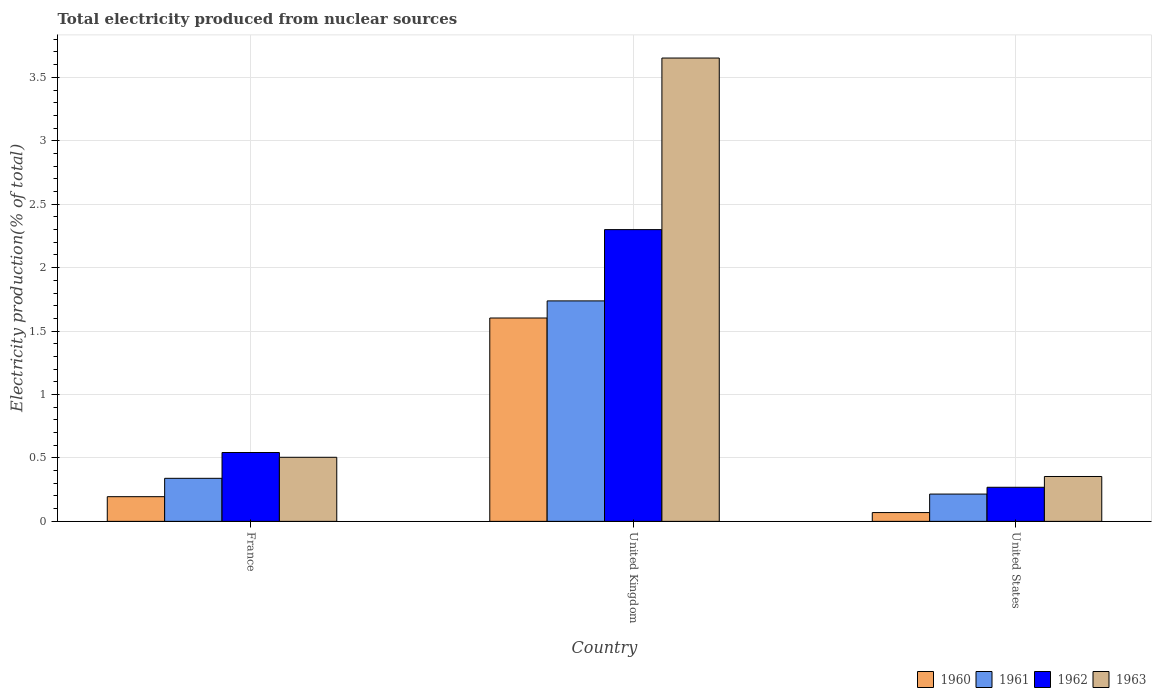Are the number of bars on each tick of the X-axis equal?
Provide a succinct answer. Yes. How many bars are there on the 3rd tick from the right?
Give a very brief answer. 4. What is the label of the 2nd group of bars from the left?
Keep it short and to the point. United Kingdom. What is the total electricity produced in 1962 in United Kingdom?
Offer a very short reply. 2.3. Across all countries, what is the maximum total electricity produced in 1961?
Your answer should be compact. 1.74. Across all countries, what is the minimum total electricity produced in 1963?
Offer a very short reply. 0.35. What is the total total electricity produced in 1960 in the graph?
Provide a short and direct response. 1.87. What is the difference between the total electricity produced in 1962 in France and that in United States?
Your response must be concise. 0.27. What is the difference between the total electricity produced in 1963 in United Kingdom and the total electricity produced in 1960 in France?
Your answer should be compact. 3.46. What is the average total electricity produced in 1962 per country?
Ensure brevity in your answer.  1.04. What is the difference between the total electricity produced of/in 1961 and total electricity produced of/in 1963 in France?
Offer a terse response. -0.17. What is the ratio of the total electricity produced in 1962 in United Kingdom to that in United States?
Ensure brevity in your answer.  8.56. Is the total electricity produced in 1960 in France less than that in United States?
Your answer should be very brief. No. Is the difference between the total electricity produced in 1961 in France and United Kingdom greater than the difference between the total electricity produced in 1963 in France and United Kingdom?
Provide a succinct answer. Yes. What is the difference between the highest and the second highest total electricity produced in 1962?
Keep it short and to the point. 0.27. What is the difference between the highest and the lowest total electricity produced in 1962?
Provide a short and direct response. 2.03. Is the sum of the total electricity produced in 1962 in France and United States greater than the maximum total electricity produced in 1963 across all countries?
Give a very brief answer. No. Is it the case that in every country, the sum of the total electricity produced in 1961 and total electricity produced in 1963 is greater than the sum of total electricity produced in 1960 and total electricity produced in 1962?
Provide a succinct answer. No. What does the 2nd bar from the left in United Kingdom represents?
Make the answer very short. 1961. Is it the case that in every country, the sum of the total electricity produced in 1961 and total electricity produced in 1960 is greater than the total electricity produced in 1962?
Provide a succinct answer. No. How many bars are there?
Provide a succinct answer. 12. Are all the bars in the graph horizontal?
Your answer should be compact. No. What is the difference between two consecutive major ticks on the Y-axis?
Ensure brevity in your answer.  0.5. Are the values on the major ticks of Y-axis written in scientific E-notation?
Make the answer very short. No. How many legend labels are there?
Provide a succinct answer. 4. What is the title of the graph?
Keep it short and to the point. Total electricity produced from nuclear sources. Does "2010" appear as one of the legend labels in the graph?
Your response must be concise. No. What is the label or title of the X-axis?
Your response must be concise. Country. What is the Electricity production(% of total) of 1960 in France?
Make the answer very short. 0.19. What is the Electricity production(% of total) of 1961 in France?
Ensure brevity in your answer.  0.34. What is the Electricity production(% of total) in 1962 in France?
Your response must be concise. 0.54. What is the Electricity production(% of total) of 1963 in France?
Give a very brief answer. 0.51. What is the Electricity production(% of total) of 1960 in United Kingdom?
Give a very brief answer. 1.6. What is the Electricity production(% of total) in 1961 in United Kingdom?
Give a very brief answer. 1.74. What is the Electricity production(% of total) in 1962 in United Kingdom?
Your answer should be compact. 2.3. What is the Electricity production(% of total) in 1963 in United Kingdom?
Keep it short and to the point. 3.65. What is the Electricity production(% of total) in 1960 in United States?
Offer a terse response. 0.07. What is the Electricity production(% of total) in 1961 in United States?
Provide a short and direct response. 0.22. What is the Electricity production(% of total) in 1962 in United States?
Your response must be concise. 0.27. What is the Electricity production(% of total) in 1963 in United States?
Your answer should be compact. 0.35. Across all countries, what is the maximum Electricity production(% of total) of 1960?
Provide a short and direct response. 1.6. Across all countries, what is the maximum Electricity production(% of total) in 1961?
Keep it short and to the point. 1.74. Across all countries, what is the maximum Electricity production(% of total) of 1962?
Keep it short and to the point. 2.3. Across all countries, what is the maximum Electricity production(% of total) in 1963?
Ensure brevity in your answer.  3.65. Across all countries, what is the minimum Electricity production(% of total) in 1960?
Provide a short and direct response. 0.07. Across all countries, what is the minimum Electricity production(% of total) in 1961?
Make the answer very short. 0.22. Across all countries, what is the minimum Electricity production(% of total) of 1962?
Give a very brief answer. 0.27. Across all countries, what is the minimum Electricity production(% of total) of 1963?
Offer a terse response. 0.35. What is the total Electricity production(% of total) in 1960 in the graph?
Give a very brief answer. 1.87. What is the total Electricity production(% of total) of 1961 in the graph?
Provide a short and direct response. 2.29. What is the total Electricity production(% of total) of 1962 in the graph?
Your answer should be compact. 3.11. What is the total Electricity production(% of total) in 1963 in the graph?
Keep it short and to the point. 4.51. What is the difference between the Electricity production(% of total) in 1960 in France and that in United Kingdom?
Provide a short and direct response. -1.41. What is the difference between the Electricity production(% of total) of 1961 in France and that in United Kingdom?
Keep it short and to the point. -1.4. What is the difference between the Electricity production(% of total) of 1962 in France and that in United Kingdom?
Give a very brief answer. -1.76. What is the difference between the Electricity production(% of total) of 1963 in France and that in United Kingdom?
Your response must be concise. -3.15. What is the difference between the Electricity production(% of total) of 1960 in France and that in United States?
Your response must be concise. 0.13. What is the difference between the Electricity production(% of total) in 1961 in France and that in United States?
Keep it short and to the point. 0.12. What is the difference between the Electricity production(% of total) in 1962 in France and that in United States?
Provide a succinct answer. 0.27. What is the difference between the Electricity production(% of total) in 1963 in France and that in United States?
Ensure brevity in your answer.  0.15. What is the difference between the Electricity production(% of total) of 1960 in United Kingdom and that in United States?
Provide a succinct answer. 1.53. What is the difference between the Electricity production(% of total) in 1961 in United Kingdom and that in United States?
Offer a terse response. 1.52. What is the difference between the Electricity production(% of total) in 1962 in United Kingdom and that in United States?
Keep it short and to the point. 2.03. What is the difference between the Electricity production(% of total) in 1963 in United Kingdom and that in United States?
Keep it short and to the point. 3.3. What is the difference between the Electricity production(% of total) in 1960 in France and the Electricity production(% of total) in 1961 in United Kingdom?
Offer a terse response. -1.54. What is the difference between the Electricity production(% of total) of 1960 in France and the Electricity production(% of total) of 1962 in United Kingdom?
Your answer should be compact. -2.11. What is the difference between the Electricity production(% of total) of 1960 in France and the Electricity production(% of total) of 1963 in United Kingdom?
Keep it short and to the point. -3.46. What is the difference between the Electricity production(% of total) in 1961 in France and the Electricity production(% of total) in 1962 in United Kingdom?
Your answer should be compact. -1.96. What is the difference between the Electricity production(% of total) of 1961 in France and the Electricity production(% of total) of 1963 in United Kingdom?
Provide a short and direct response. -3.31. What is the difference between the Electricity production(% of total) in 1962 in France and the Electricity production(% of total) in 1963 in United Kingdom?
Your answer should be compact. -3.11. What is the difference between the Electricity production(% of total) in 1960 in France and the Electricity production(% of total) in 1961 in United States?
Keep it short and to the point. -0.02. What is the difference between the Electricity production(% of total) of 1960 in France and the Electricity production(% of total) of 1962 in United States?
Provide a short and direct response. -0.07. What is the difference between the Electricity production(% of total) in 1960 in France and the Electricity production(% of total) in 1963 in United States?
Offer a very short reply. -0.16. What is the difference between the Electricity production(% of total) of 1961 in France and the Electricity production(% of total) of 1962 in United States?
Give a very brief answer. 0.07. What is the difference between the Electricity production(% of total) of 1961 in France and the Electricity production(% of total) of 1963 in United States?
Ensure brevity in your answer.  -0.01. What is the difference between the Electricity production(% of total) of 1962 in France and the Electricity production(% of total) of 1963 in United States?
Your answer should be compact. 0.19. What is the difference between the Electricity production(% of total) in 1960 in United Kingdom and the Electricity production(% of total) in 1961 in United States?
Offer a very short reply. 1.39. What is the difference between the Electricity production(% of total) of 1960 in United Kingdom and the Electricity production(% of total) of 1962 in United States?
Your answer should be compact. 1.33. What is the difference between the Electricity production(% of total) in 1960 in United Kingdom and the Electricity production(% of total) in 1963 in United States?
Provide a succinct answer. 1.25. What is the difference between the Electricity production(% of total) in 1961 in United Kingdom and the Electricity production(% of total) in 1962 in United States?
Offer a very short reply. 1.47. What is the difference between the Electricity production(% of total) in 1961 in United Kingdom and the Electricity production(% of total) in 1963 in United States?
Offer a terse response. 1.38. What is the difference between the Electricity production(% of total) in 1962 in United Kingdom and the Electricity production(% of total) in 1963 in United States?
Make the answer very short. 1.95. What is the average Electricity production(% of total) in 1960 per country?
Your response must be concise. 0.62. What is the average Electricity production(% of total) in 1961 per country?
Provide a short and direct response. 0.76. What is the average Electricity production(% of total) of 1962 per country?
Give a very brief answer. 1.04. What is the average Electricity production(% of total) in 1963 per country?
Your answer should be compact. 1.5. What is the difference between the Electricity production(% of total) of 1960 and Electricity production(% of total) of 1961 in France?
Your response must be concise. -0.14. What is the difference between the Electricity production(% of total) of 1960 and Electricity production(% of total) of 1962 in France?
Provide a short and direct response. -0.35. What is the difference between the Electricity production(% of total) in 1960 and Electricity production(% of total) in 1963 in France?
Ensure brevity in your answer.  -0.31. What is the difference between the Electricity production(% of total) of 1961 and Electricity production(% of total) of 1962 in France?
Offer a very short reply. -0.2. What is the difference between the Electricity production(% of total) in 1961 and Electricity production(% of total) in 1963 in France?
Your answer should be very brief. -0.17. What is the difference between the Electricity production(% of total) of 1962 and Electricity production(% of total) of 1963 in France?
Offer a terse response. 0.04. What is the difference between the Electricity production(% of total) of 1960 and Electricity production(% of total) of 1961 in United Kingdom?
Your answer should be compact. -0.13. What is the difference between the Electricity production(% of total) in 1960 and Electricity production(% of total) in 1962 in United Kingdom?
Provide a succinct answer. -0.7. What is the difference between the Electricity production(% of total) in 1960 and Electricity production(% of total) in 1963 in United Kingdom?
Your answer should be very brief. -2.05. What is the difference between the Electricity production(% of total) of 1961 and Electricity production(% of total) of 1962 in United Kingdom?
Give a very brief answer. -0.56. What is the difference between the Electricity production(% of total) of 1961 and Electricity production(% of total) of 1963 in United Kingdom?
Your response must be concise. -1.91. What is the difference between the Electricity production(% of total) in 1962 and Electricity production(% of total) in 1963 in United Kingdom?
Your answer should be very brief. -1.35. What is the difference between the Electricity production(% of total) of 1960 and Electricity production(% of total) of 1961 in United States?
Your response must be concise. -0.15. What is the difference between the Electricity production(% of total) in 1960 and Electricity production(% of total) in 1962 in United States?
Give a very brief answer. -0.2. What is the difference between the Electricity production(% of total) in 1960 and Electricity production(% of total) in 1963 in United States?
Offer a very short reply. -0.28. What is the difference between the Electricity production(% of total) in 1961 and Electricity production(% of total) in 1962 in United States?
Your response must be concise. -0.05. What is the difference between the Electricity production(% of total) of 1961 and Electricity production(% of total) of 1963 in United States?
Make the answer very short. -0.14. What is the difference between the Electricity production(% of total) of 1962 and Electricity production(% of total) of 1963 in United States?
Provide a succinct answer. -0.09. What is the ratio of the Electricity production(% of total) in 1960 in France to that in United Kingdom?
Your response must be concise. 0.12. What is the ratio of the Electricity production(% of total) of 1961 in France to that in United Kingdom?
Give a very brief answer. 0.2. What is the ratio of the Electricity production(% of total) in 1962 in France to that in United Kingdom?
Offer a very short reply. 0.24. What is the ratio of the Electricity production(% of total) of 1963 in France to that in United Kingdom?
Your answer should be very brief. 0.14. What is the ratio of the Electricity production(% of total) of 1960 in France to that in United States?
Ensure brevity in your answer.  2.81. What is the ratio of the Electricity production(% of total) in 1961 in France to that in United States?
Your response must be concise. 1.58. What is the ratio of the Electricity production(% of total) in 1962 in France to that in United States?
Provide a short and direct response. 2.02. What is the ratio of the Electricity production(% of total) in 1963 in France to that in United States?
Provide a succinct answer. 1.43. What is the ratio of the Electricity production(% of total) in 1960 in United Kingdom to that in United States?
Provide a succinct answer. 23.14. What is the ratio of the Electricity production(% of total) in 1961 in United Kingdom to that in United States?
Provide a short and direct response. 8.08. What is the ratio of the Electricity production(% of total) in 1962 in United Kingdom to that in United States?
Ensure brevity in your answer.  8.56. What is the ratio of the Electricity production(% of total) in 1963 in United Kingdom to that in United States?
Keep it short and to the point. 10.32. What is the difference between the highest and the second highest Electricity production(% of total) of 1960?
Ensure brevity in your answer.  1.41. What is the difference between the highest and the second highest Electricity production(% of total) in 1961?
Provide a succinct answer. 1.4. What is the difference between the highest and the second highest Electricity production(% of total) in 1962?
Your answer should be compact. 1.76. What is the difference between the highest and the second highest Electricity production(% of total) in 1963?
Ensure brevity in your answer.  3.15. What is the difference between the highest and the lowest Electricity production(% of total) in 1960?
Your answer should be compact. 1.53. What is the difference between the highest and the lowest Electricity production(% of total) of 1961?
Keep it short and to the point. 1.52. What is the difference between the highest and the lowest Electricity production(% of total) of 1962?
Your answer should be compact. 2.03. What is the difference between the highest and the lowest Electricity production(% of total) in 1963?
Your answer should be compact. 3.3. 